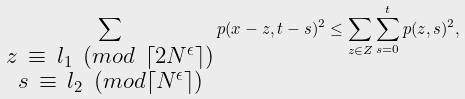<formula> <loc_0><loc_0><loc_500><loc_500>\sum _ { \substack { z \ \equiv \ l _ { 1 } \ ( m o d \ \lceil 2 N ^ { \epsilon } \rceil ) \\ s \ \equiv \ l _ { 2 } \ ( m o d \lceil N ^ { \epsilon } \rceil ) } } p ( x - z , t - s ) ^ { 2 } & \leq \sum _ { z \in Z } \sum _ { s = 0 } ^ { t } p ( z , s ) ^ { 2 } ,</formula> 